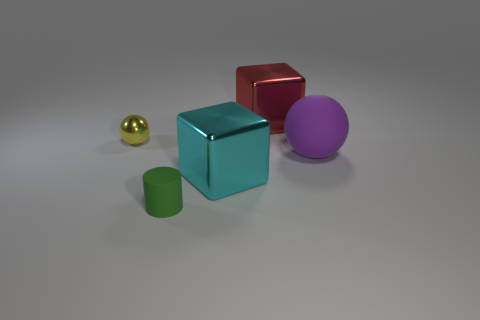There is a large metallic block to the right of the large metallic object in front of the big red metallic block; what is its color?
Offer a very short reply. Red. How many small metallic objects have the same color as the tiny matte cylinder?
Ensure brevity in your answer.  0. Is the color of the tiny matte thing the same as the thing that is left of the small green thing?
Give a very brief answer. No. Are there fewer gray matte cylinders than tiny green things?
Provide a short and direct response. Yes. Are there more big cyan metallic blocks behind the large cyan block than large rubber balls that are to the left of the red block?
Your answer should be very brief. No. Is the yellow thing made of the same material as the cyan object?
Keep it short and to the point. Yes. There is a object that is behind the tiny metallic thing; how many purple matte objects are to the right of it?
Offer a terse response. 1. There is a large object that is to the right of the red metal block; is it the same color as the tiny sphere?
Offer a terse response. No. What number of objects are either big red matte spheres or metallic cubes to the left of the red shiny object?
Make the answer very short. 1. There is a tiny thing behind the tiny green matte object; is it the same shape as the big shiny thing in front of the purple rubber sphere?
Your answer should be compact. No. 